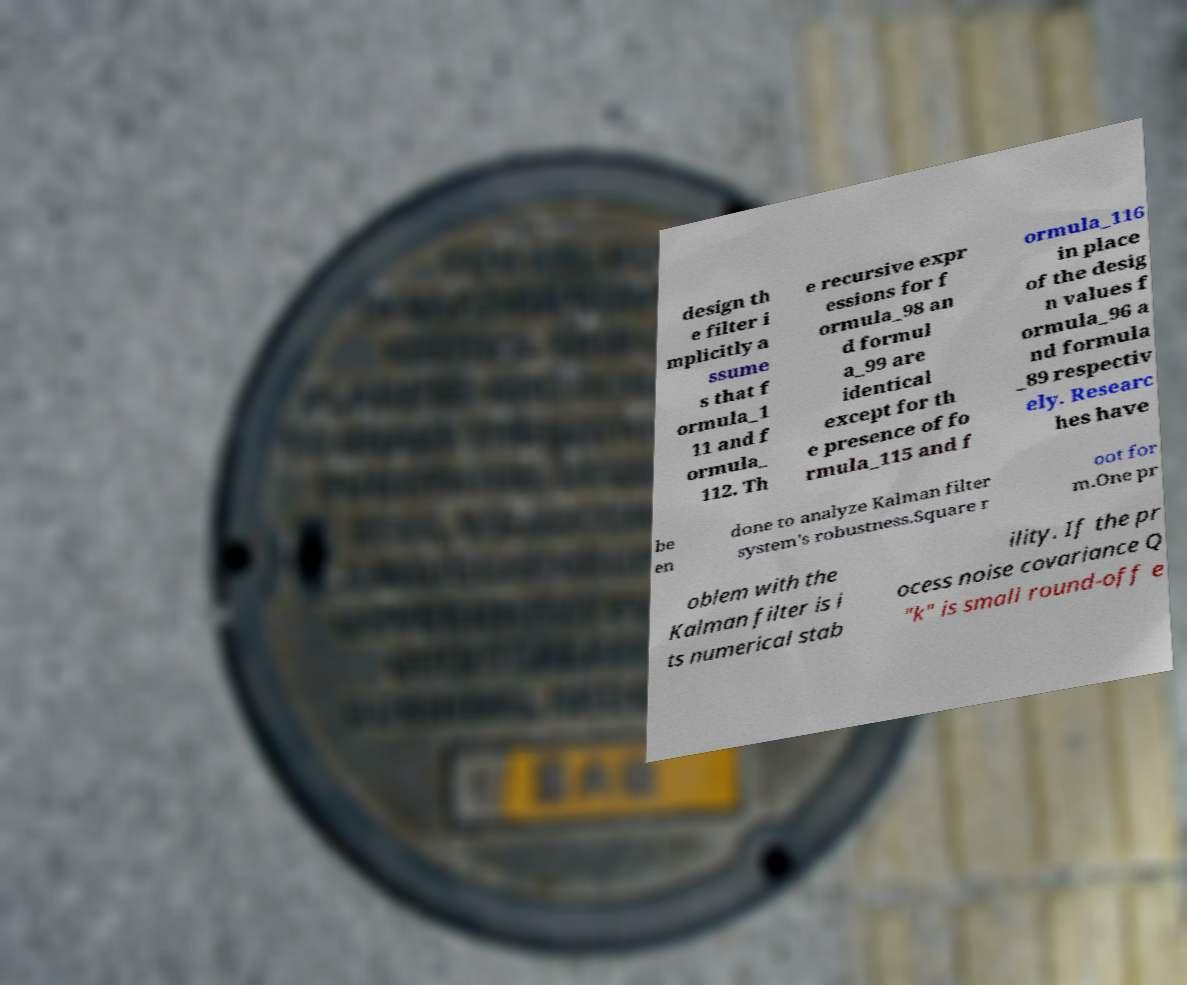Could you extract and type out the text from this image? design th e filter i mplicitly a ssume s that f ormula_1 11 and f ormula_ 112. Th e recursive expr essions for f ormula_98 an d formul a_99 are identical except for th e presence of fo rmula_115 and f ormula_116 in place of the desig n values f ormula_96 a nd formula _89 respectiv ely. Researc hes have be en done to analyze Kalman filter system's robustness.Square r oot for m.One pr oblem with the Kalman filter is i ts numerical stab ility. If the pr ocess noise covariance Q "k" is small round-off e 